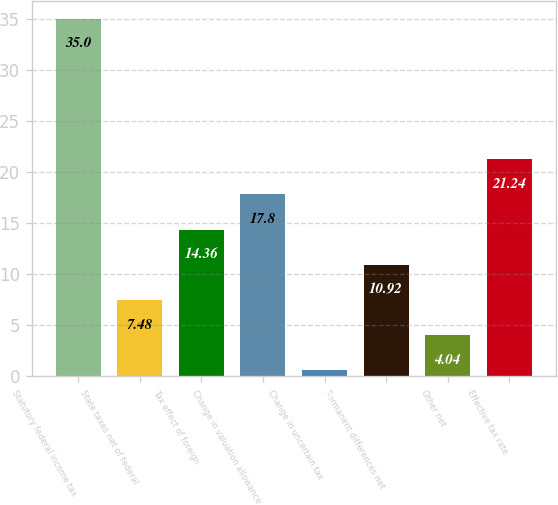Convert chart. <chart><loc_0><loc_0><loc_500><loc_500><bar_chart><fcel>Statutory federal income tax<fcel>State taxes net of federal<fcel>Tax effect of foreign<fcel>Change in valuation allowance<fcel>Change in uncertain tax<fcel>Permanent differences net<fcel>Other net<fcel>Effective tax rate<nl><fcel>35<fcel>7.48<fcel>14.36<fcel>17.8<fcel>0.6<fcel>10.92<fcel>4.04<fcel>21.24<nl></chart> 